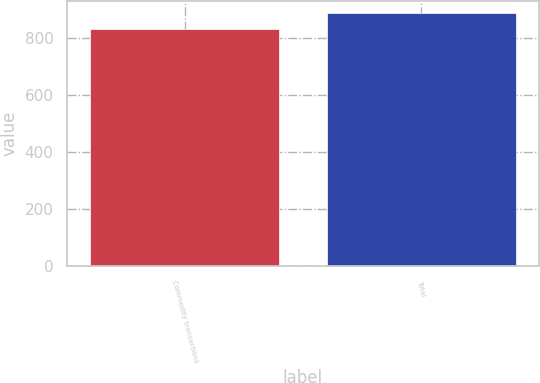<chart> <loc_0><loc_0><loc_500><loc_500><bar_chart><fcel>Commodity transactions<fcel>Total<nl><fcel>833<fcel>888<nl></chart> 